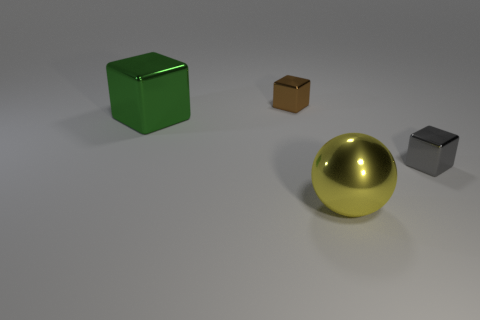Subtract all big cubes. How many cubes are left? 2 Add 4 large rubber cylinders. How many objects exist? 8 Subtract 2 cubes. How many cubes are left? 1 Subtract all gray cubes. How many cubes are left? 2 Subtract all blocks. How many objects are left? 1 Add 2 yellow spheres. How many yellow spheres exist? 3 Subtract 1 brown blocks. How many objects are left? 3 Subtract all brown blocks. Subtract all purple cylinders. How many blocks are left? 2 Subtract all red cylinders. How many gray spheres are left? 0 Subtract all cyan blocks. Subtract all tiny metal objects. How many objects are left? 2 